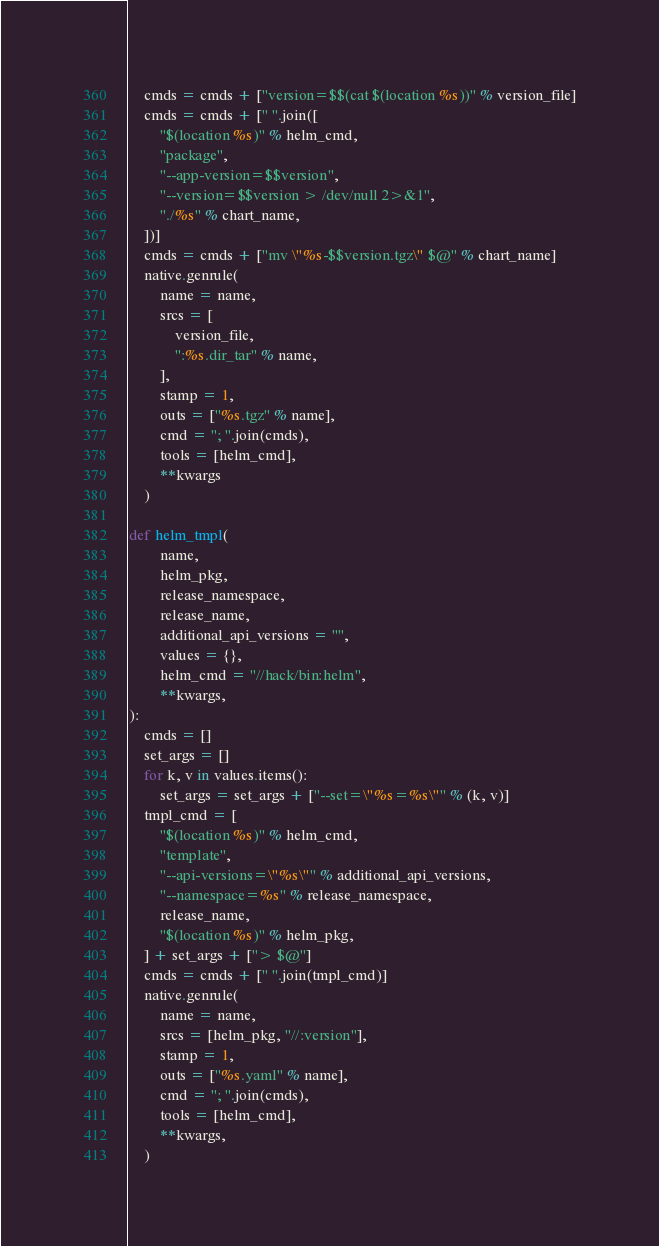<code> <loc_0><loc_0><loc_500><loc_500><_Python_>    cmds = cmds + ["version=$$(cat $(location %s))" % version_file]
    cmds = cmds + [" ".join([
        "$(location %s)" % helm_cmd,
        "package",
        "--app-version=$$version",
        "--version=$$version > /dev/null 2>&1",
        "./%s" % chart_name,
    ])]
    cmds = cmds + ["mv \"%s-$$version.tgz\" $@" % chart_name]
    native.genrule(
        name = name,
        srcs = [
            version_file,
            ":%s.dir_tar" % name,
        ],
        stamp = 1,
        outs = ["%s.tgz" % name],
        cmd = "; ".join(cmds),
        tools = [helm_cmd],
        **kwargs
    )

def helm_tmpl(
        name,
        helm_pkg,
        release_namespace,
        release_name,
        additional_api_versions = "",
        values = {},
        helm_cmd = "//hack/bin:helm",
        **kwargs,
):
    cmds = []
    set_args = []
    for k, v in values.items():
        set_args = set_args + ["--set=\"%s=%s\"" % (k, v)]
    tmpl_cmd = [
        "$(location %s)" % helm_cmd,
        "template",
        "--api-versions=\"%s\"" % additional_api_versions,
        "--namespace=%s" % release_namespace,
        release_name,
        "$(location %s)" % helm_pkg,
    ] + set_args + ["> $@"]
    cmds = cmds + [" ".join(tmpl_cmd)]
    native.genrule(
        name = name,
        srcs = [helm_pkg, "//:version"],
        stamp = 1,
        outs = ["%s.yaml" % name],
        cmd = "; ".join(cmds),
        tools = [helm_cmd],
        **kwargs,
    )
</code> 